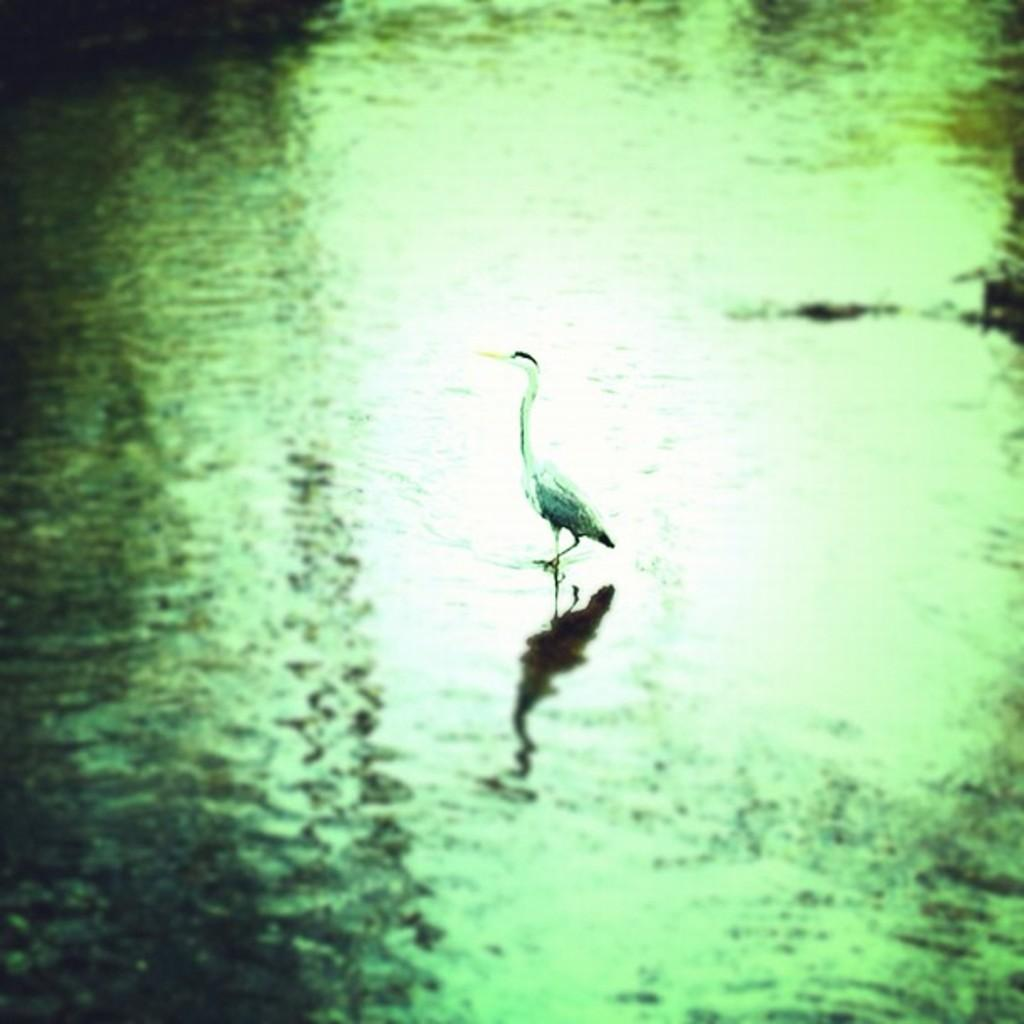What is the main subject of the image? The main subject of the image is a crane. What is the crane doing in the image? The crane is walking in the water. What type of statement can be seen written on the window in the image? There is no window or statement present in the image; it features a crane walking in the water. 